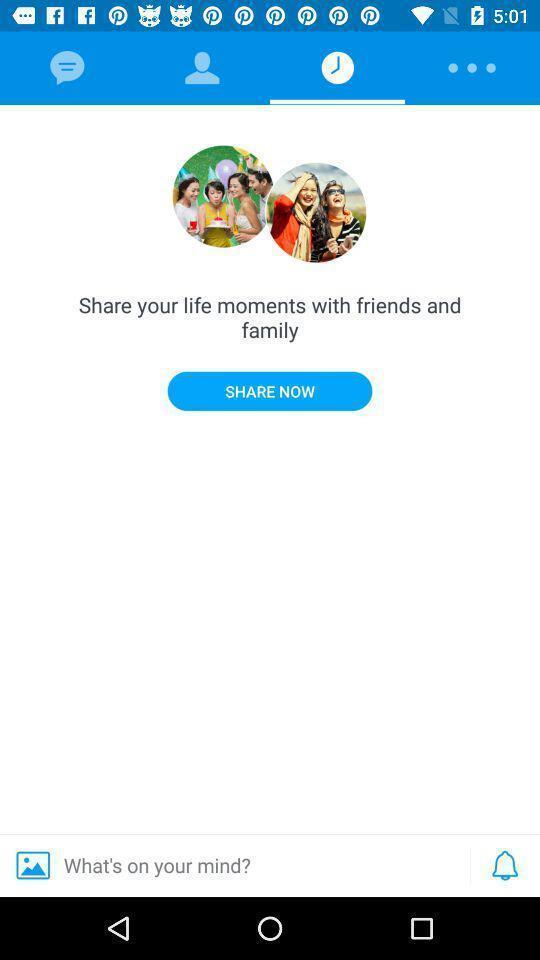Describe this image in words. Starting page. 